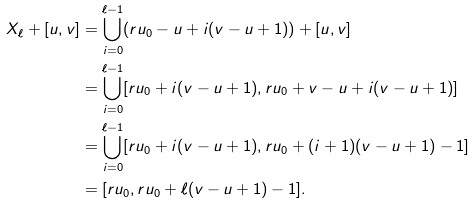Convert formula to latex. <formula><loc_0><loc_0><loc_500><loc_500>X _ { \ell } + [ u , v ] & = \bigcup _ { i = 0 } ^ { \ell - 1 } ( r u _ { 0 } - u + i ( v - u + 1 ) ) + [ u , v ] \\ & = \bigcup _ { i = 0 } ^ { \ell - 1 } [ r u _ { 0 } + i ( v - u + 1 ) , r u _ { 0 } + v - u + i ( v - u + 1 ) ] \\ & = \bigcup _ { i = 0 } ^ { \ell - 1 } [ r u _ { 0 } + i ( v - u + 1 ) , r u _ { 0 } + ( i + 1 ) ( v - u + 1 ) - 1 ] \\ & = [ r u _ { 0 } , r u _ { 0 } + \ell ( v - u + 1 ) - 1 ] .</formula> 